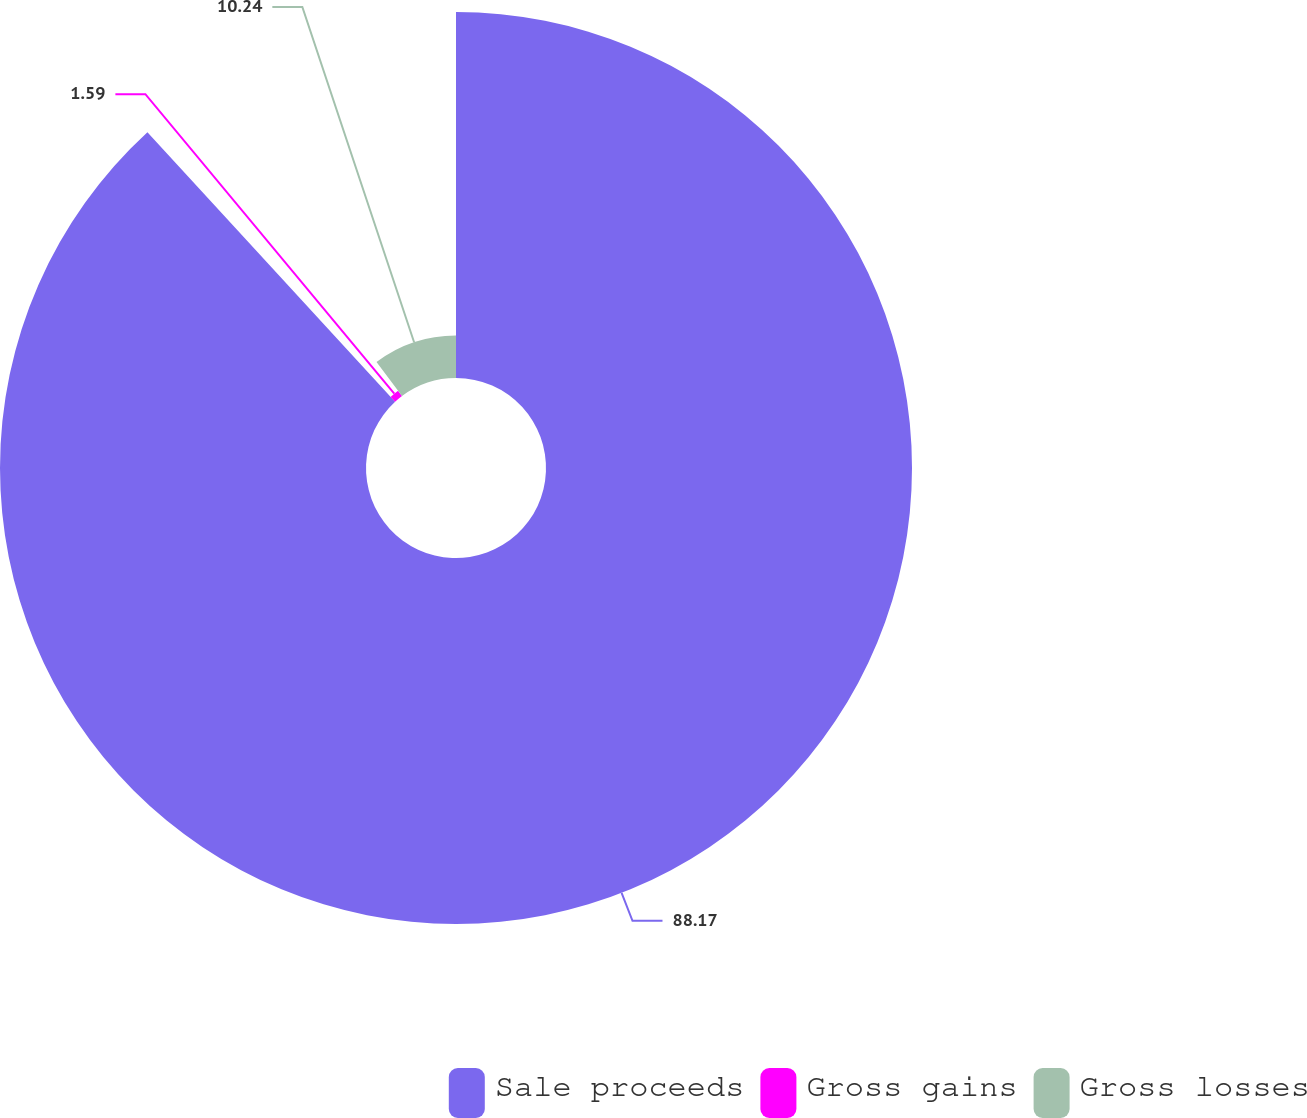<chart> <loc_0><loc_0><loc_500><loc_500><pie_chart><fcel>Sale proceeds<fcel>Gross gains<fcel>Gross losses<nl><fcel>88.17%<fcel>1.59%<fcel>10.24%<nl></chart> 